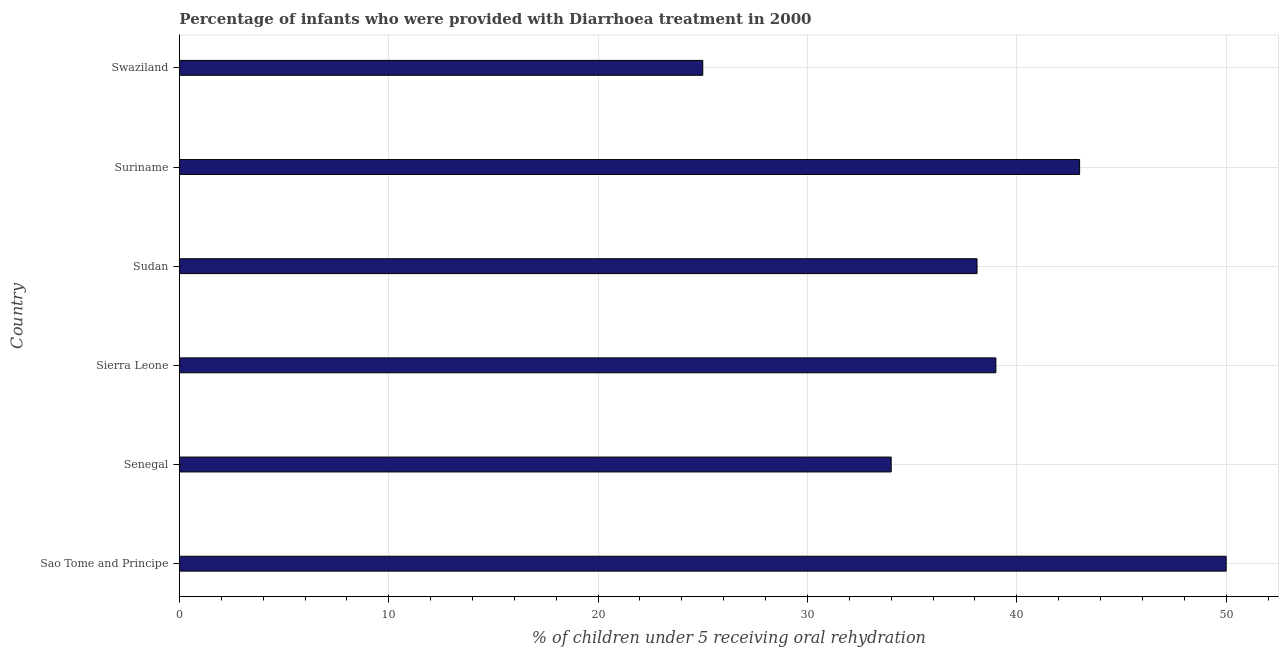What is the title of the graph?
Offer a terse response. Percentage of infants who were provided with Diarrhoea treatment in 2000. What is the label or title of the X-axis?
Provide a short and direct response. % of children under 5 receiving oral rehydration. Across all countries, what is the minimum percentage of children who were provided with treatment diarrhoea?
Give a very brief answer. 25. In which country was the percentage of children who were provided with treatment diarrhoea maximum?
Your answer should be compact. Sao Tome and Principe. In which country was the percentage of children who were provided with treatment diarrhoea minimum?
Your answer should be very brief. Swaziland. What is the sum of the percentage of children who were provided with treatment diarrhoea?
Your answer should be very brief. 229.1. What is the difference between the percentage of children who were provided with treatment diarrhoea in Sierra Leone and Sudan?
Your response must be concise. 0.9. What is the average percentage of children who were provided with treatment diarrhoea per country?
Provide a short and direct response. 38.18. What is the median percentage of children who were provided with treatment diarrhoea?
Your answer should be very brief. 38.55. In how many countries, is the percentage of children who were provided with treatment diarrhoea greater than 32 %?
Ensure brevity in your answer.  5. Is the percentage of children who were provided with treatment diarrhoea in Sao Tome and Principe less than that in Sudan?
Your response must be concise. No. Is the difference between the percentage of children who were provided with treatment diarrhoea in Sudan and Swaziland greater than the difference between any two countries?
Ensure brevity in your answer.  No. Is the sum of the percentage of children who were provided with treatment diarrhoea in Sierra Leone and Sudan greater than the maximum percentage of children who were provided with treatment diarrhoea across all countries?
Make the answer very short. Yes. What is the difference between the highest and the lowest percentage of children who were provided with treatment diarrhoea?
Provide a succinct answer. 25. How many bars are there?
Offer a terse response. 6. Are all the bars in the graph horizontal?
Make the answer very short. Yes. How many countries are there in the graph?
Make the answer very short. 6. What is the difference between two consecutive major ticks on the X-axis?
Provide a short and direct response. 10. Are the values on the major ticks of X-axis written in scientific E-notation?
Keep it short and to the point. No. What is the % of children under 5 receiving oral rehydration in Sao Tome and Principe?
Your answer should be compact. 50. What is the % of children under 5 receiving oral rehydration in Senegal?
Your response must be concise. 34. What is the % of children under 5 receiving oral rehydration of Sudan?
Provide a short and direct response. 38.1. What is the % of children under 5 receiving oral rehydration of Swaziland?
Give a very brief answer. 25. What is the difference between the % of children under 5 receiving oral rehydration in Sao Tome and Principe and Sierra Leone?
Give a very brief answer. 11. What is the difference between the % of children under 5 receiving oral rehydration in Senegal and Sudan?
Offer a very short reply. -4.1. What is the difference between the % of children under 5 receiving oral rehydration in Senegal and Swaziland?
Your response must be concise. 9. What is the difference between the % of children under 5 receiving oral rehydration in Sierra Leone and Suriname?
Keep it short and to the point. -4. What is the difference between the % of children under 5 receiving oral rehydration in Sierra Leone and Swaziland?
Offer a terse response. 14. What is the difference between the % of children under 5 receiving oral rehydration in Sudan and Suriname?
Keep it short and to the point. -4.9. What is the ratio of the % of children under 5 receiving oral rehydration in Sao Tome and Principe to that in Senegal?
Provide a succinct answer. 1.47. What is the ratio of the % of children under 5 receiving oral rehydration in Sao Tome and Principe to that in Sierra Leone?
Your answer should be very brief. 1.28. What is the ratio of the % of children under 5 receiving oral rehydration in Sao Tome and Principe to that in Sudan?
Provide a succinct answer. 1.31. What is the ratio of the % of children under 5 receiving oral rehydration in Sao Tome and Principe to that in Suriname?
Provide a short and direct response. 1.16. What is the ratio of the % of children under 5 receiving oral rehydration in Senegal to that in Sierra Leone?
Offer a very short reply. 0.87. What is the ratio of the % of children under 5 receiving oral rehydration in Senegal to that in Sudan?
Make the answer very short. 0.89. What is the ratio of the % of children under 5 receiving oral rehydration in Senegal to that in Suriname?
Keep it short and to the point. 0.79. What is the ratio of the % of children under 5 receiving oral rehydration in Senegal to that in Swaziland?
Provide a succinct answer. 1.36. What is the ratio of the % of children under 5 receiving oral rehydration in Sierra Leone to that in Suriname?
Keep it short and to the point. 0.91. What is the ratio of the % of children under 5 receiving oral rehydration in Sierra Leone to that in Swaziland?
Keep it short and to the point. 1.56. What is the ratio of the % of children under 5 receiving oral rehydration in Sudan to that in Suriname?
Ensure brevity in your answer.  0.89. What is the ratio of the % of children under 5 receiving oral rehydration in Sudan to that in Swaziland?
Offer a very short reply. 1.52. What is the ratio of the % of children under 5 receiving oral rehydration in Suriname to that in Swaziland?
Make the answer very short. 1.72. 